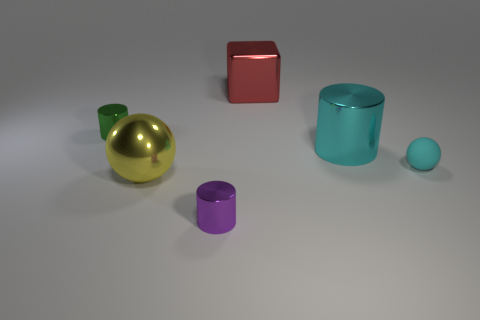Is the number of large metal things greater than the number of blocks?
Your response must be concise. Yes. Are the green cylinder and the large cube made of the same material?
Your answer should be compact. Yes. How many matte objects are gray spheres or yellow things?
Offer a very short reply. 0. What color is the matte ball that is the same size as the green object?
Your answer should be compact. Cyan. How many other shiny things are the same shape as the yellow shiny object?
Provide a short and direct response. 0. What number of spheres are either small blue things or tiny things?
Provide a succinct answer. 1. Does the cyan thing that is on the left side of the cyan ball have the same shape as the big object on the left side of the red metallic thing?
Provide a short and direct response. No. What material is the big yellow ball?
Keep it short and to the point. Metal. What is the shape of the metal thing that is the same color as the small matte object?
Provide a succinct answer. Cylinder. What number of gray metal balls have the same size as the green cylinder?
Provide a short and direct response. 0. 